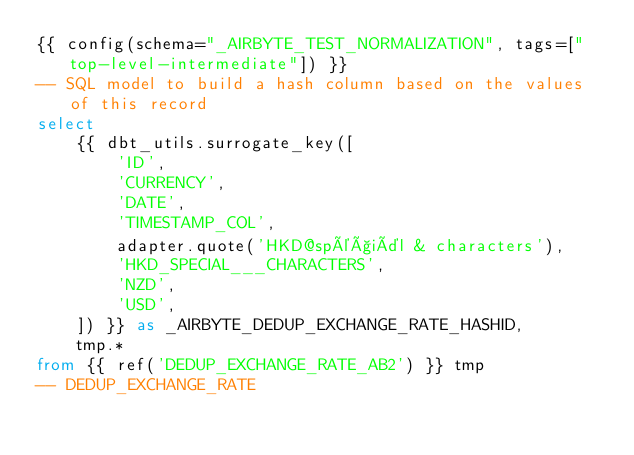Convert code to text. <code><loc_0><loc_0><loc_500><loc_500><_SQL_>{{ config(schema="_AIRBYTE_TEST_NORMALIZATION", tags=["top-level-intermediate"]) }}
-- SQL model to build a hash column based on the values of this record
select
    {{ dbt_utils.surrogate_key([
        'ID',
        'CURRENCY',
        'DATE',
        'TIMESTAMP_COL',
        adapter.quote('HKD@spéçiäl & characters'),
        'HKD_SPECIAL___CHARACTERS',
        'NZD',
        'USD',
    ]) }} as _AIRBYTE_DEDUP_EXCHANGE_RATE_HASHID,
    tmp.*
from {{ ref('DEDUP_EXCHANGE_RATE_AB2') }} tmp
-- DEDUP_EXCHANGE_RATE

</code> 